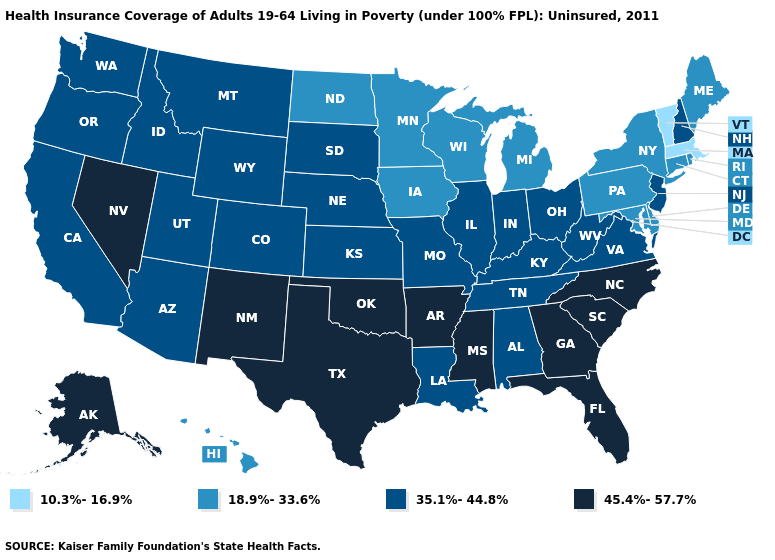Which states have the lowest value in the Northeast?
Write a very short answer. Massachusetts, Vermont. What is the highest value in the USA?
Quick response, please. 45.4%-57.7%. Among the states that border Colorado , does Oklahoma have the highest value?
Write a very short answer. Yes. Does New Hampshire have the highest value in the Northeast?
Quick response, please. Yes. Name the states that have a value in the range 35.1%-44.8%?
Keep it brief. Alabama, Arizona, California, Colorado, Idaho, Illinois, Indiana, Kansas, Kentucky, Louisiana, Missouri, Montana, Nebraska, New Hampshire, New Jersey, Ohio, Oregon, South Dakota, Tennessee, Utah, Virginia, Washington, West Virginia, Wyoming. What is the value of Idaho?
Be succinct. 35.1%-44.8%. Which states have the lowest value in the USA?
Give a very brief answer. Massachusetts, Vermont. What is the lowest value in the USA?
Write a very short answer. 10.3%-16.9%. Does Maine have a higher value than Massachusetts?
Keep it brief. Yes. What is the value of Louisiana?
Quick response, please. 35.1%-44.8%. Among the states that border Oregon , does Nevada have the highest value?
Keep it brief. Yes. Does Kansas have the highest value in the MidWest?
Quick response, please. Yes. Does Nevada have a higher value than Iowa?
Write a very short answer. Yes. What is the highest value in states that border Washington?
Write a very short answer. 35.1%-44.8%. Name the states that have a value in the range 18.9%-33.6%?
Be succinct. Connecticut, Delaware, Hawaii, Iowa, Maine, Maryland, Michigan, Minnesota, New York, North Dakota, Pennsylvania, Rhode Island, Wisconsin. 